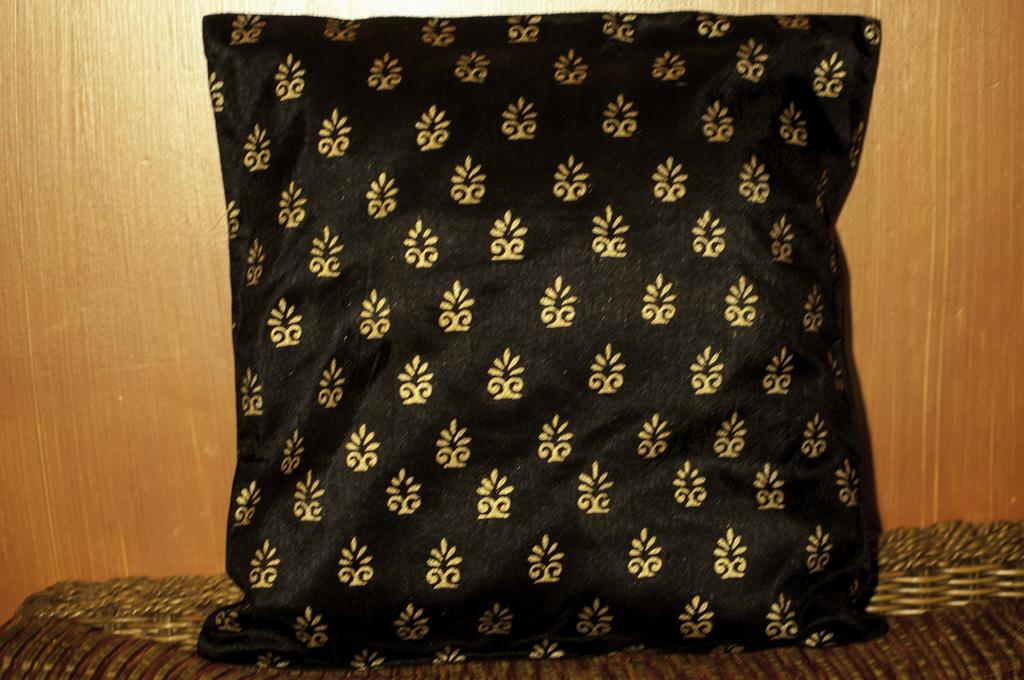What is present on the object in the image? There is a pillow in the image. What is the pillow resting on? The pillow is on an object. What type of wall can be seen in the background of the image? There is a wooden wall in the background of the image. What song is the hen singing in the image? There is no hen or song present in the image. 